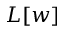<formula> <loc_0><loc_0><loc_500><loc_500>L [ w ]</formula> 